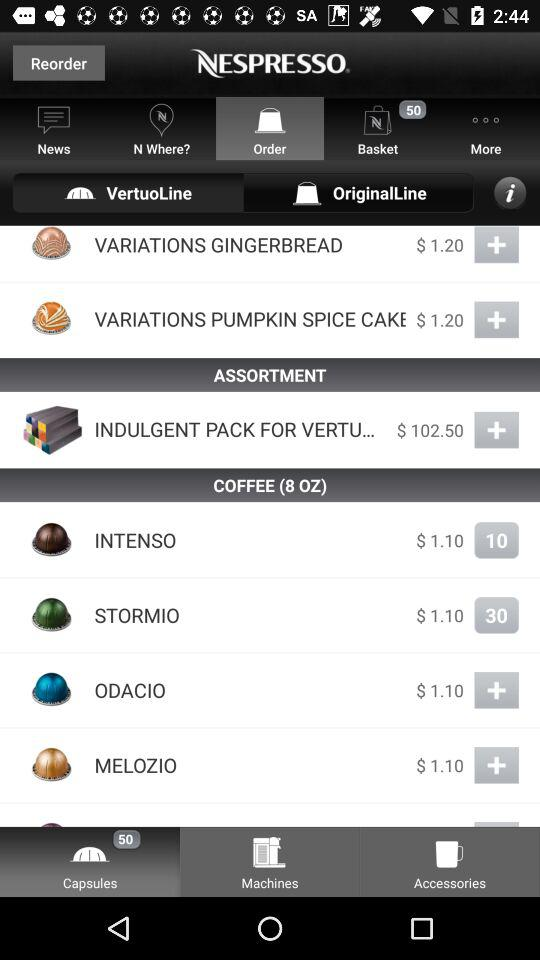How much does "STORMIO" cost?
Answer the question using a single word or phrase. "STORMIO" costs $1.10. 